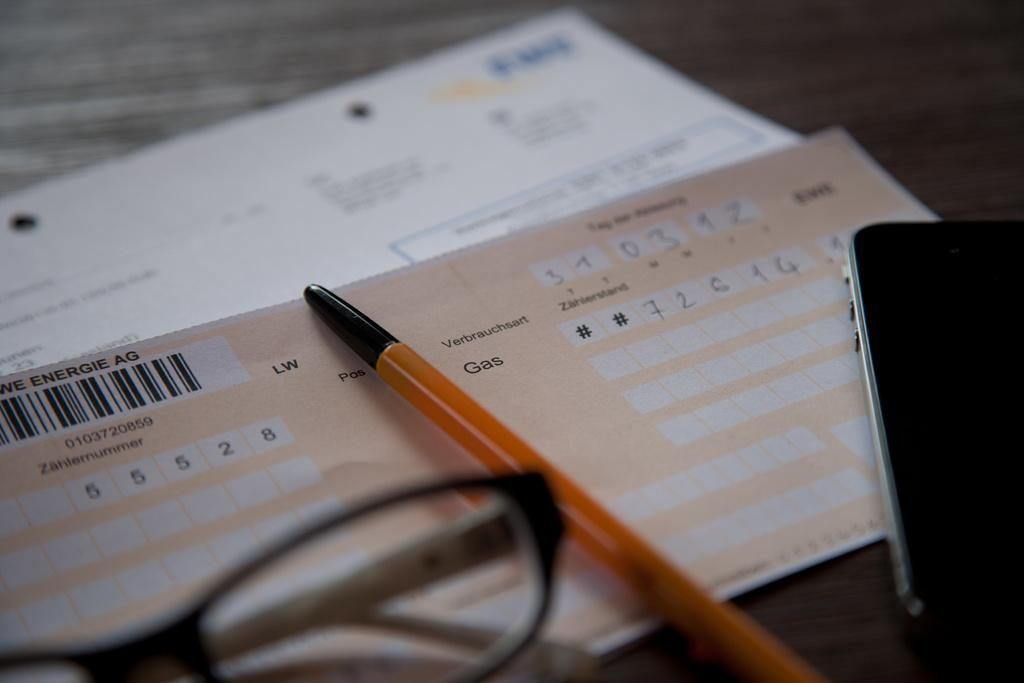<image>
Provide a brief description of the given image. an orange colored bill displaying Zählernummer 55528 with a pen on top of it 